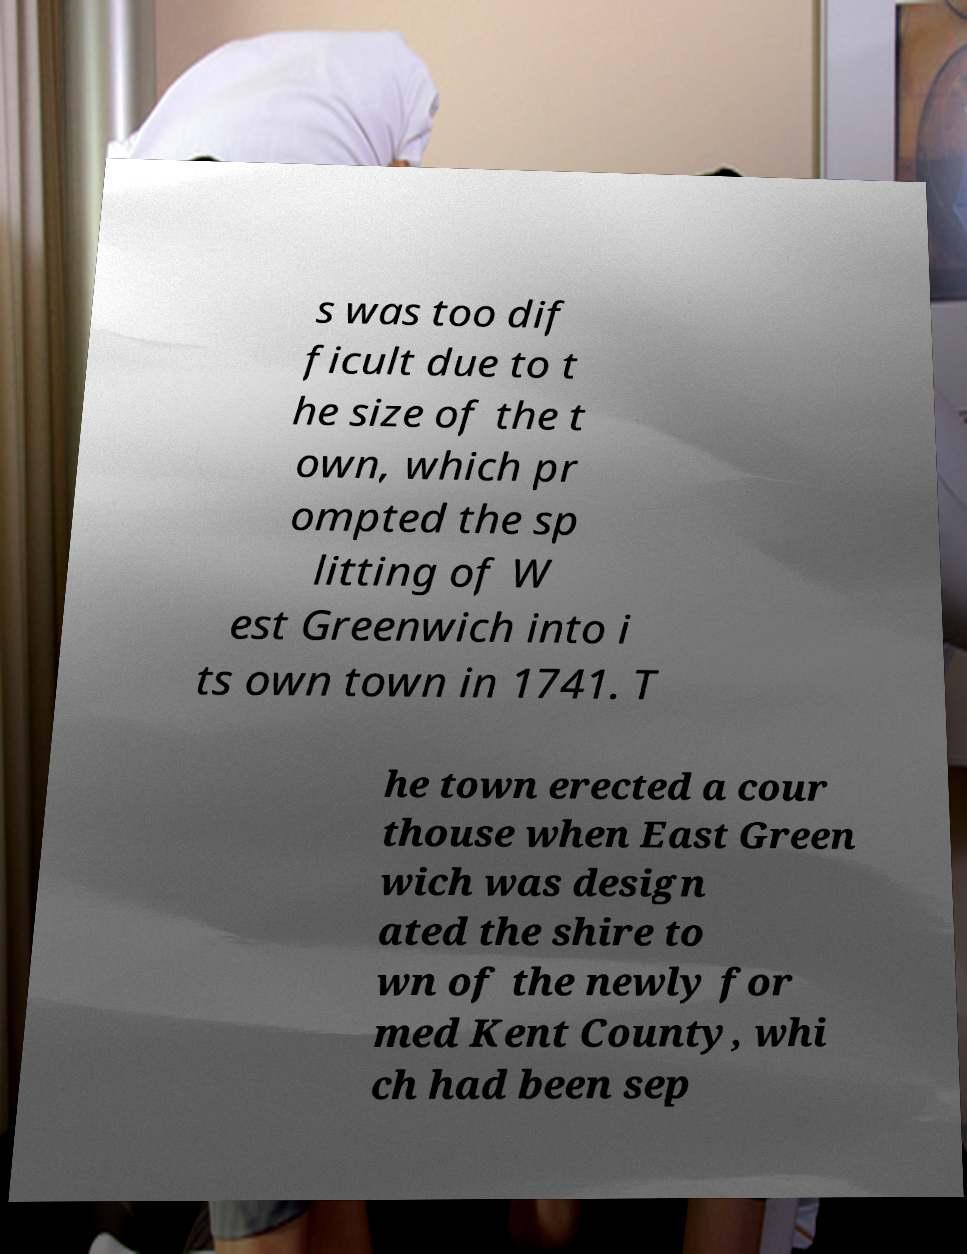I need the written content from this picture converted into text. Can you do that? s was too dif ficult due to t he size of the t own, which pr ompted the sp litting of W est Greenwich into i ts own town in 1741. T he town erected a cour thouse when East Green wich was design ated the shire to wn of the newly for med Kent County, whi ch had been sep 